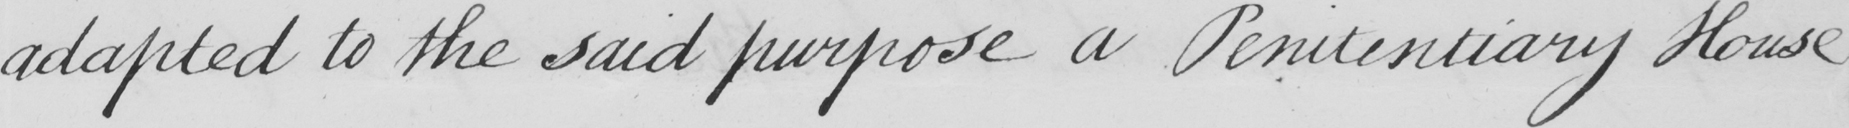Can you read and transcribe this handwriting? adapted to the said purpose a Penitentiary House 